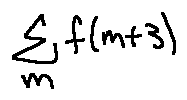Convert formula to latex. <formula><loc_0><loc_0><loc_500><loc_500>\sum \lim i t s _ { m } f ( m + 3 )</formula> 